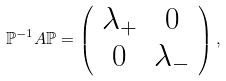Convert formula to latex. <formula><loc_0><loc_0><loc_500><loc_500>\mathbb { P } ^ { - 1 } A \mathbb { P } = \left ( \begin{array} { c c } \lambda _ { + } & 0 \\ 0 & \lambda _ { - } \\ \end{array} \right ) ,</formula> 